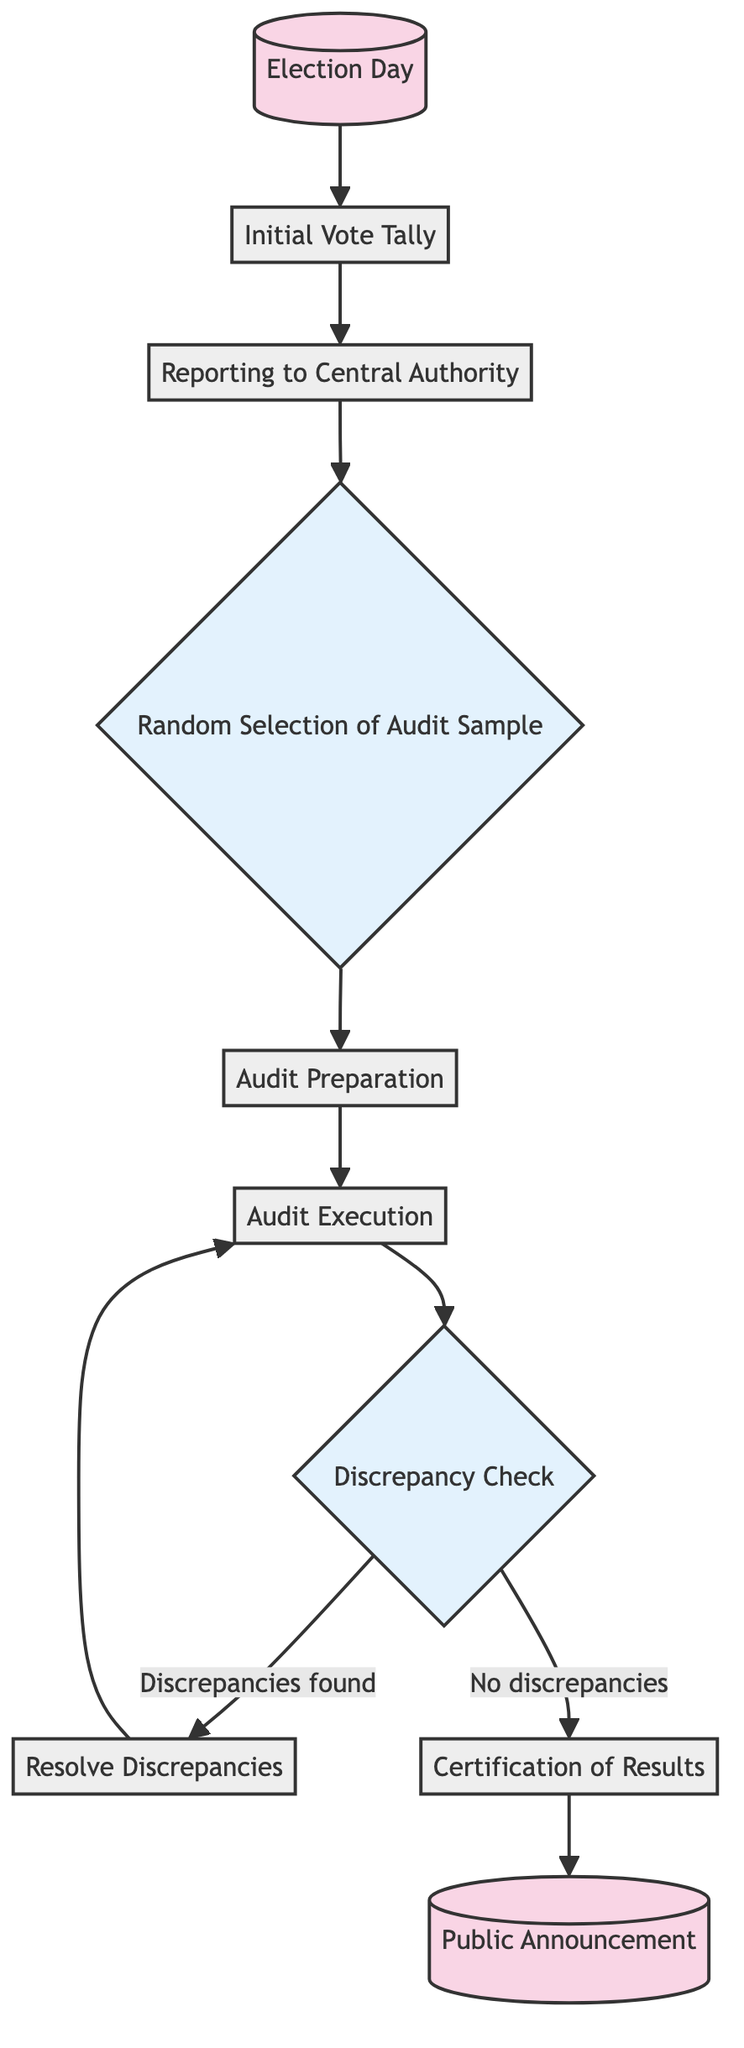What is the first event in the workflow? The first event is labeled as "Election Day," which signifies the beginning of the electoral process.
Answer: Election Day How many processes are there in total? There are six processes identified in the diagram: "Initial Vote Tally," "Reporting to Central Authority," "Audit Preparation," "Audit Execution," "Resolve Discrepancies," and "Certification of Results."
Answer: six What happens after the "Reporting to Central Authority"? After "Reporting to Central Authority," the next step is "Random Selection of Audit Sample," which is a critical decision point in the workflow.
Answer: Random Selection of Audit Sample What decision leads to the "Resolve Discrepancies" process? The decision that leads to "Resolve Discrepancies" is the "Discrepancy Check," when discrepancies are found during the audit execution.
Answer: Discrepancy Check What is the outcome if no discrepancies are found? If no discrepancies are found, the next step is "Certification of Results," indicating that the results can be certified based on the audit's findings.
Answer: Certification of Results How many events are there in the diagram? There are two events in the workflow: "Election Day" and "Public Announcement."
Answer: two What is the last step in the workflow? The last step in the workflow is "Public Announcement," which conveys the official results to the public following certification.
Answer: Public Announcement What process follows after "Audit Execution"? The process that follows "Audit Execution" is "Discrepancy Check," which examines the results for any inconsistencies.
Answer: Discrepancy Check What is the relationship between “Audit Preparation” and “Audit Execution”? "Audit Preparation" directly leads to "Audit Execution," as preparing the selected ballots or polls is essential before executing the audit.
Answer: leads to 